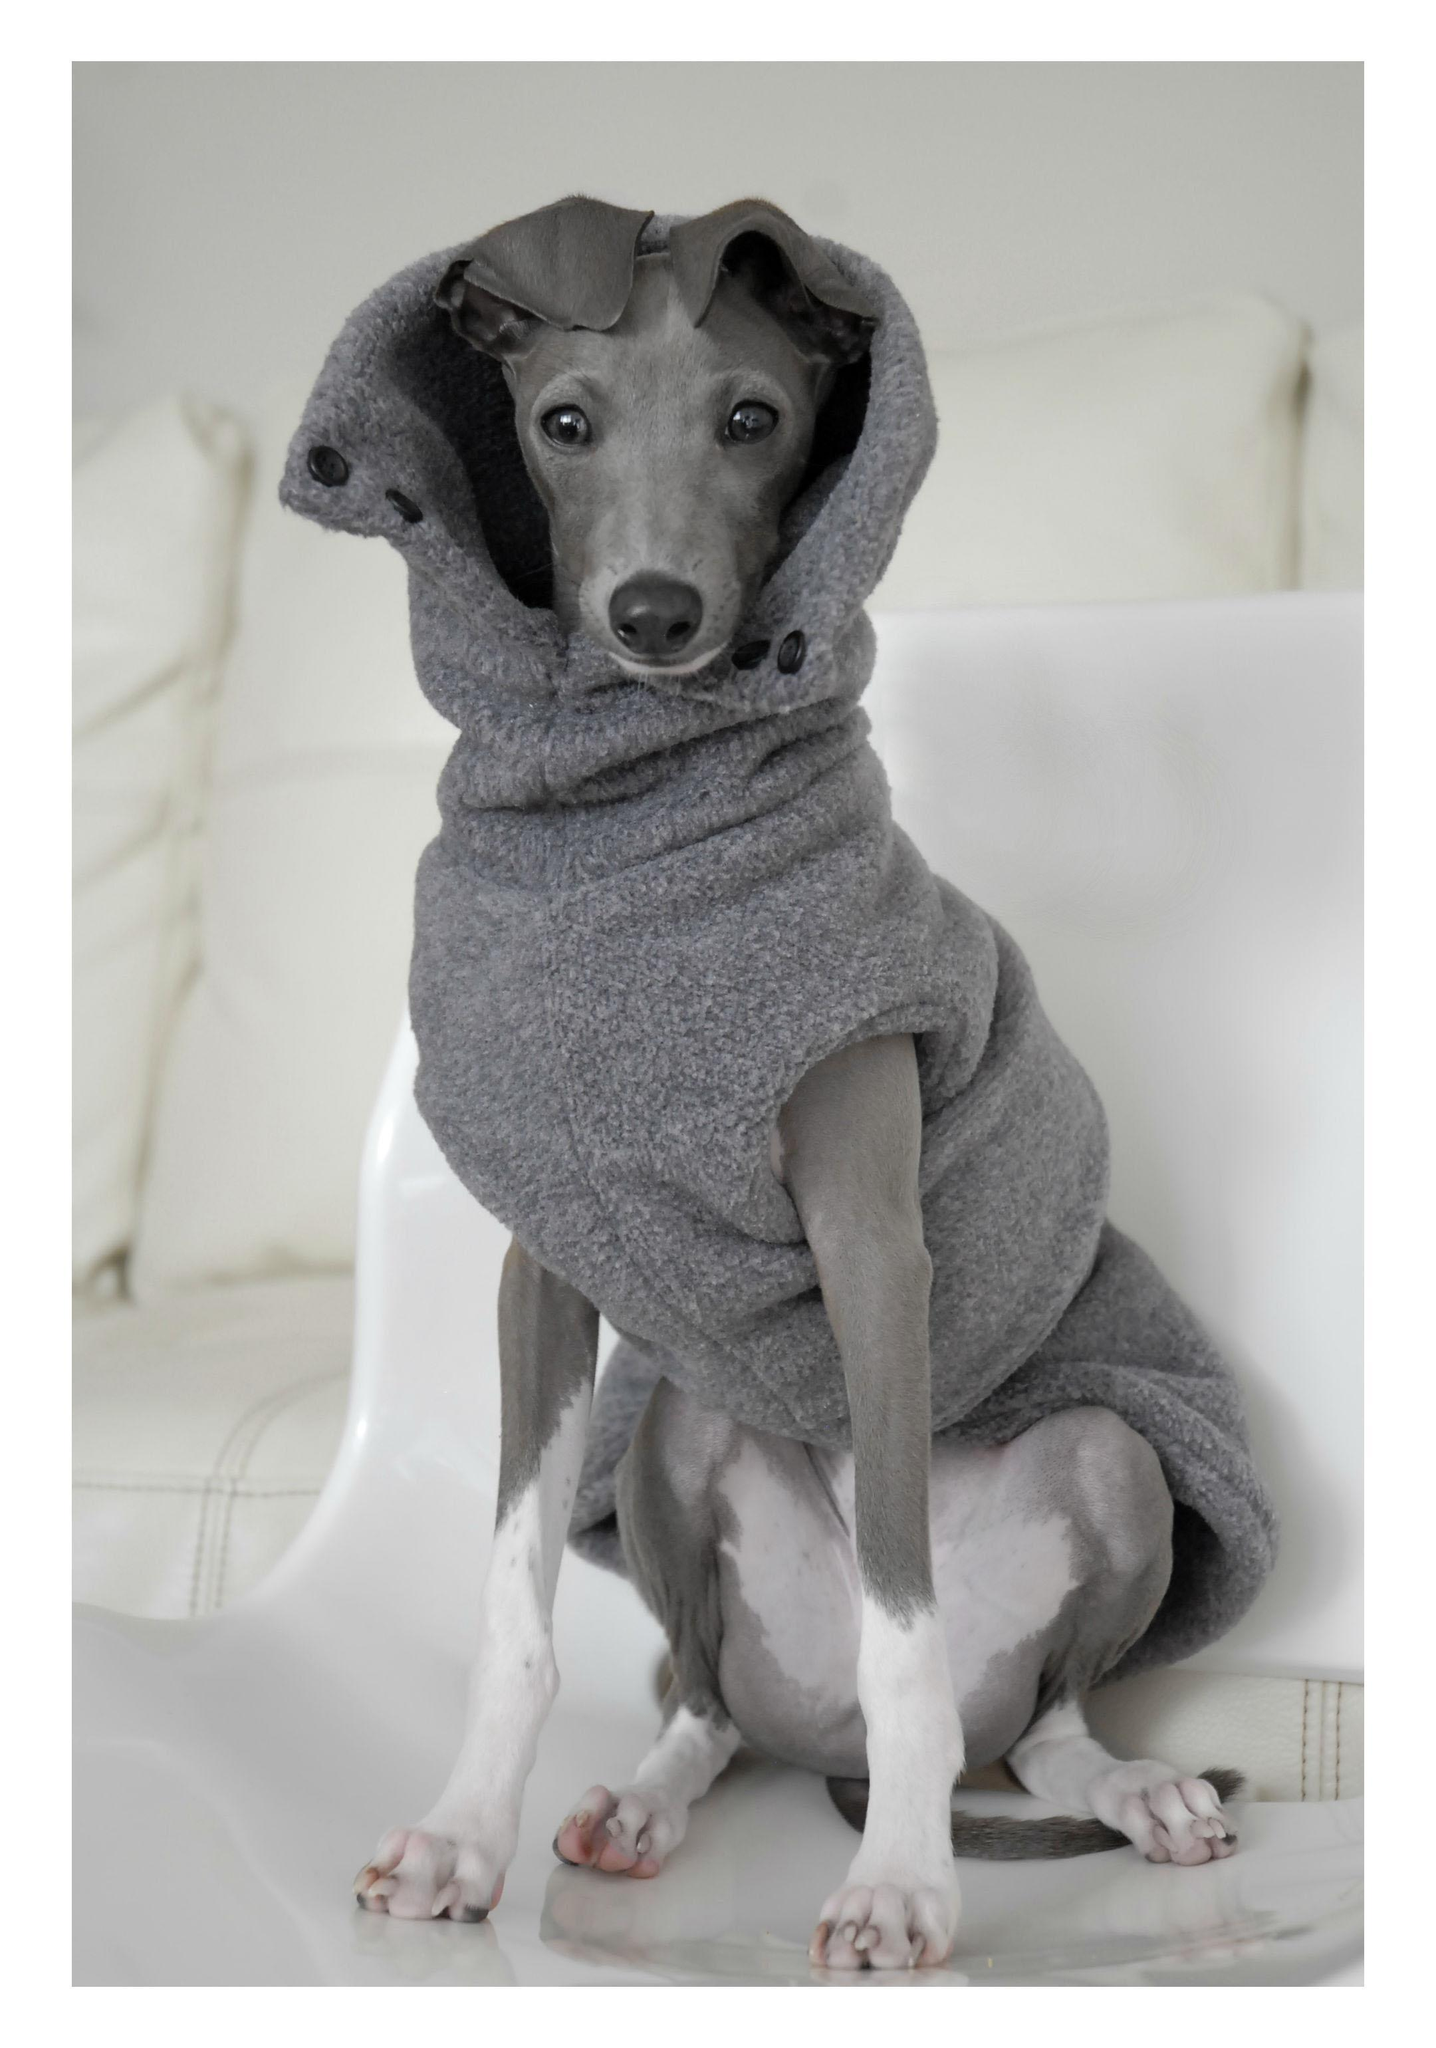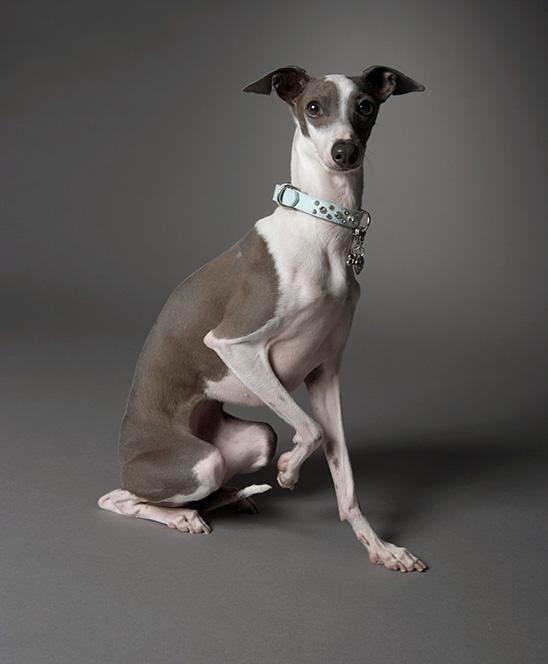The first image is the image on the left, the second image is the image on the right. For the images shown, is this caption "One image shows one non-spotted dog in a standing pose." true? Answer yes or no. No. The first image is the image on the left, the second image is the image on the right. For the images displayed, is the sentence "At least one of the dogs is standing on all fours." factually correct? Answer yes or no. No. 